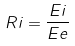<formula> <loc_0><loc_0><loc_500><loc_500>R i = \frac { E i } { E e }</formula> 